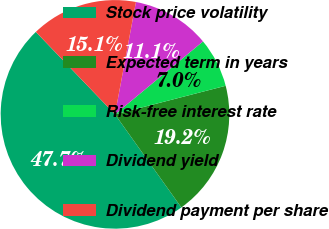Convert chart. <chart><loc_0><loc_0><loc_500><loc_500><pie_chart><fcel>Stock price volatility<fcel>Expected term in years<fcel>Risk-free interest rate<fcel>Dividend yield<fcel>Dividend payment per share<nl><fcel>47.68%<fcel>19.17%<fcel>6.99%<fcel>11.05%<fcel>15.11%<nl></chart> 